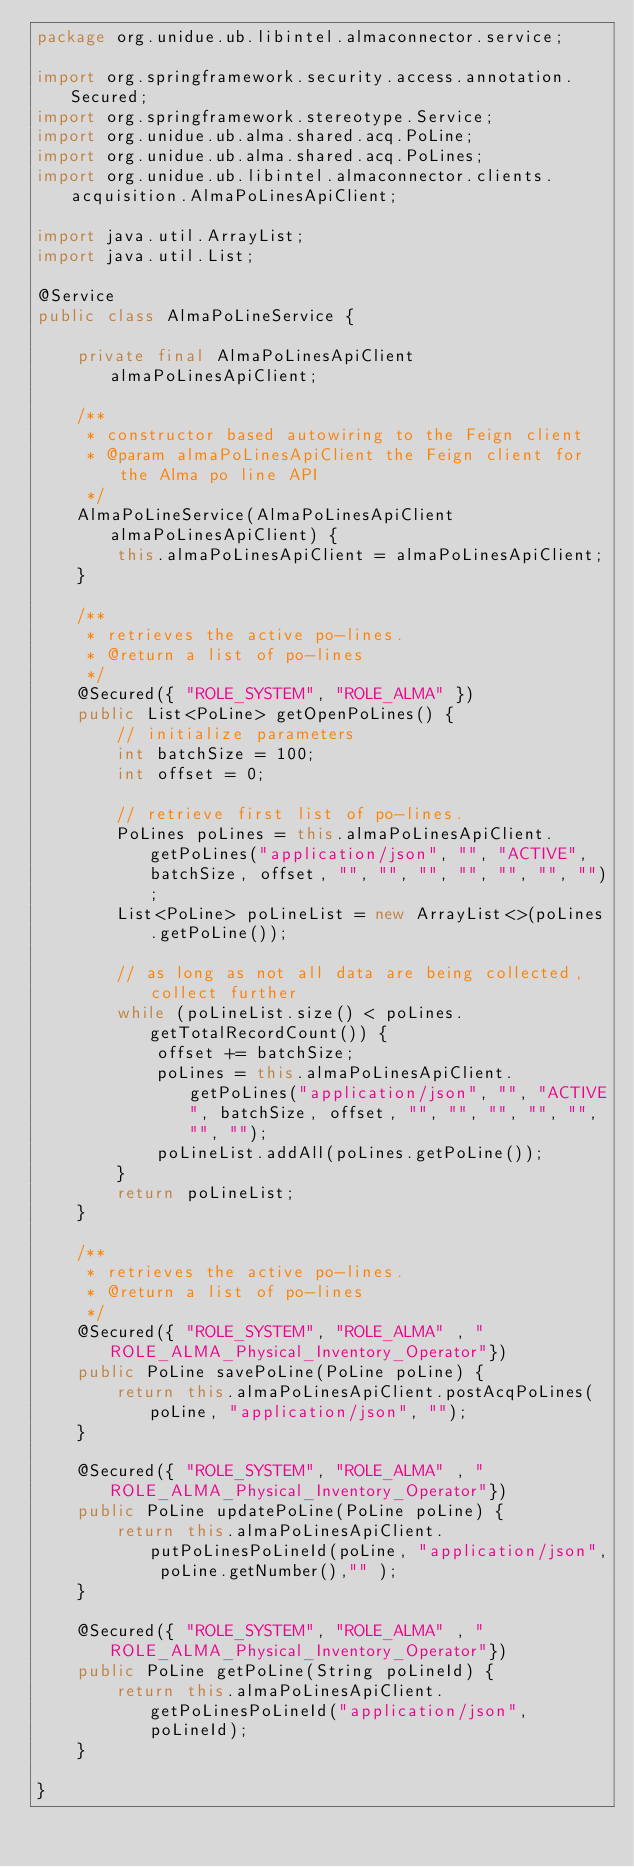Convert code to text. <code><loc_0><loc_0><loc_500><loc_500><_Java_>package org.unidue.ub.libintel.almaconnector.service;

import org.springframework.security.access.annotation.Secured;
import org.springframework.stereotype.Service;
import org.unidue.ub.alma.shared.acq.PoLine;
import org.unidue.ub.alma.shared.acq.PoLines;
import org.unidue.ub.libintel.almaconnector.clients.acquisition.AlmaPoLinesApiClient;

import java.util.ArrayList;
import java.util.List;

@Service
public class AlmaPoLineService {

    private final AlmaPoLinesApiClient almaPoLinesApiClient;

    /**
     * constructor based autowiring to the Feign client
     * @param almaPoLinesApiClient the Feign client for the Alma po line API
     */
    AlmaPoLineService(AlmaPoLinesApiClient almaPoLinesApiClient) {
        this.almaPoLinesApiClient = almaPoLinesApiClient;
    }

    /**
     * retrieves the active po-lines.
     * @return a list of po-lines
     */
    @Secured({ "ROLE_SYSTEM", "ROLE_ALMA" })
    public List<PoLine> getOpenPoLines() {
        // initialize parameters
        int batchSize = 100;
        int offset = 0;

        // retrieve first list of po-lines.
        PoLines poLines = this.almaPoLinesApiClient.getPoLines("application/json", "", "ACTIVE", batchSize, offset, "", "", "", "", "", "", "");
        List<PoLine> poLineList = new ArrayList<>(poLines.getPoLine());

        // as long as not all data are being collected, collect further
        while (poLineList.size() < poLines.getTotalRecordCount()) {
            offset += batchSize;
            poLines = this.almaPoLinesApiClient.getPoLines("application/json", "", "ACTIVE", batchSize, offset, "", "", "", "", "", "", "");
            poLineList.addAll(poLines.getPoLine());
        }
        return poLineList;
    }

    /**
     * retrieves the active po-lines.
     * @return a list of po-lines
     */
    @Secured({ "ROLE_SYSTEM", "ROLE_ALMA" , "ROLE_ALMA_Physical_Inventory_Operator"})
    public PoLine savePoLine(PoLine poLine) {
        return this.almaPoLinesApiClient.postAcqPoLines(poLine, "application/json", "");
    }

    @Secured({ "ROLE_SYSTEM", "ROLE_ALMA" , "ROLE_ALMA_Physical_Inventory_Operator"})
    public PoLine updatePoLine(PoLine poLine) {
        return this.almaPoLinesApiClient.putPoLinesPoLineId(poLine, "application/json", poLine.getNumber(),"" );
    }

    @Secured({ "ROLE_SYSTEM", "ROLE_ALMA" , "ROLE_ALMA_Physical_Inventory_Operator"})
    public PoLine getPoLine(String poLineId) {
        return this.almaPoLinesApiClient.getPoLinesPoLineId("application/json", poLineId);
    }

}
</code> 